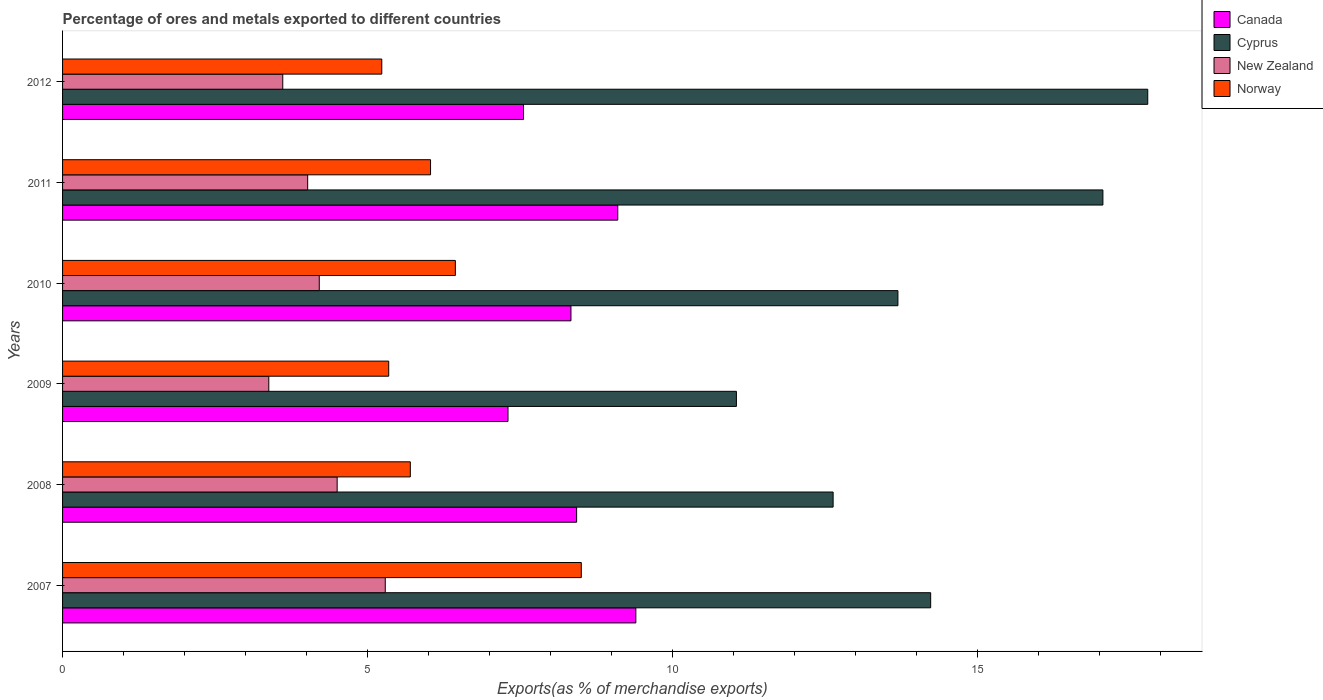How many groups of bars are there?
Provide a short and direct response. 6. How many bars are there on the 6th tick from the bottom?
Provide a succinct answer. 4. What is the label of the 5th group of bars from the top?
Ensure brevity in your answer.  2008. What is the percentage of exports to different countries in New Zealand in 2011?
Keep it short and to the point. 4.02. Across all years, what is the maximum percentage of exports to different countries in Canada?
Provide a succinct answer. 9.4. Across all years, what is the minimum percentage of exports to different countries in Cyprus?
Give a very brief answer. 11.04. In which year was the percentage of exports to different countries in New Zealand minimum?
Provide a succinct answer. 2009. What is the total percentage of exports to different countries in Canada in the graph?
Your answer should be compact. 50.1. What is the difference between the percentage of exports to different countries in Canada in 2008 and that in 2012?
Your response must be concise. 0.87. What is the difference between the percentage of exports to different countries in Canada in 2007 and the percentage of exports to different countries in Norway in 2012?
Offer a very short reply. 4.16. What is the average percentage of exports to different countries in Cyprus per year?
Give a very brief answer. 14.4. In the year 2009, what is the difference between the percentage of exports to different countries in Canada and percentage of exports to different countries in Norway?
Your answer should be very brief. 1.95. What is the ratio of the percentage of exports to different countries in Norway in 2011 to that in 2012?
Keep it short and to the point. 1.15. Is the difference between the percentage of exports to different countries in Canada in 2007 and 2010 greater than the difference between the percentage of exports to different countries in Norway in 2007 and 2010?
Offer a very short reply. No. What is the difference between the highest and the second highest percentage of exports to different countries in Canada?
Provide a succinct answer. 0.3. What is the difference between the highest and the lowest percentage of exports to different countries in Cyprus?
Your answer should be compact. 6.74. In how many years, is the percentage of exports to different countries in New Zealand greater than the average percentage of exports to different countries in New Zealand taken over all years?
Your answer should be very brief. 3. What does the 4th bar from the top in 2009 represents?
Make the answer very short. Canada. Is it the case that in every year, the sum of the percentage of exports to different countries in Canada and percentage of exports to different countries in Norway is greater than the percentage of exports to different countries in New Zealand?
Ensure brevity in your answer.  Yes. How many bars are there?
Ensure brevity in your answer.  24. Are all the bars in the graph horizontal?
Keep it short and to the point. Yes. What is the difference between two consecutive major ticks on the X-axis?
Keep it short and to the point. 5. Are the values on the major ticks of X-axis written in scientific E-notation?
Ensure brevity in your answer.  No. Does the graph contain any zero values?
Provide a succinct answer. No. How are the legend labels stacked?
Give a very brief answer. Vertical. What is the title of the graph?
Ensure brevity in your answer.  Percentage of ores and metals exported to different countries. Does "Monaco" appear as one of the legend labels in the graph?
Offer a terse response. No. What is the label or title of the X-axis?
Ensure brevity in your answer.  Exports(as % of merchandise exports). What is the label or title of the Y-axis?
Provide a short and direct response. Years. What is the Exports(as % of merchandise exports) of Canada in 2007?
Offer a very short reply. 9.4. What is the Exports(as % of merchandise exports) in Cyprus in 2007?
Your answer should be very brief. 14.23. What is the Exports(as % of merchandise exports) of New Zealand in 2007?
Your response must be concise. 5.29. What is the Exports(as % of merchandise exports) of Norway in 2007?
Provide a succinct answer. 8.5. What is the Exports(as % of merchandise exports) in Canada in 2008?
Offer a very short reply. 8.42. What is the Exports(as % of merchandise exports) in Cyprus in 2008?
Ensure brevity in your answer.  12.63. What is the Exports(as % of merchandise exports) in New Zealand in 2008?
Provide a short and direct response. 4.5. What is the Exports(as % of merchandise exports) of Norway in 2008?
Ensure brevity in your answer.  5.7. What is the Exports(as % of merchandise exports) in Canada in 2009?
Provide a succinct answer. 7.3. What is the Exports(as % of merchandise exports) in Cyprus in 2009?
Offer a very short reply. 11.04. What is the Exports(as % of merchandise exports) in New Zealand in 2009?
Provide a short and direct response. 3.38. What is the Exports(as % of merchandise exports) in Norway in 2009?
Keep it short and to the point. 5.35. What is the Exports(as % of merchandise exports) of Canada in 2010?
Your answer should be very brief. 8.33. What is the Exports(as % of merchandise exports) of Cyprus in 2010?
Your answer should be very brief. 13.69. What is the Exports(as % of merchandise exports) of New Zealand in 2010?
Offer a terse response. 4.21. What is the Exports(as % of merchandise exports) of Norway in 2010?
Your response must be concise. 6.44. What is the Exports(as % of merchandise exports) of Canada in 2011?
Offer a terse response. 9.1. What is the Exports(as % of merchandise exports) of Cyprus in 2011?
Your response must be concise. 17.05. What is the Exports(as % of merchandise exports) in New Zealand in 2011?
Your response must be concise. 4.02. What is the Exports(as % of merchandise exports) of Norway in 2011?
Keep it short and to the point. 6.03. What is the Exports(as % of merchandise exports) in Canada in 2012?
Keep it short and to the point. 7.55. What is the Exports(as % of merchandise exports) of Cyprus in 2012?
Keep it short and to the point. 17.78. What is the Exports(as % of merchandise exports) in New Zealand in 2012?
Offer a terse response. 3.61. What is the Exports(as % of merchandise exports) of Norway in 2012?
Ensure brevity in your answer.  5.23. Across all years, what is the maximum Exports(as % of merchandise exports) of Canada?
Make the answer very short. 9.4. Across all years, what is the maximum Exports(as % of merchandise exports) in Cyprus?
Provide a succinct answer. 17.78. Across all years, what is the maximum Exports(as % of merchandise exports) in New Zealand?
Offer a very short reply. 5.29. Across all years, what is the maximum Exports(as % of merchandise exports) in Norway?
Offer a very short reply. 8.5. Across all years, what is the minimum Exports(as % of merchandise exports) in Canada?
Give a very brief answer. 7.3. Across all years, what is the minimum Exports(as % of merchandise exports) in Cyprus?
Your answer should be very brief. 11.04. Across all years, what is the minimum Exports(as % of merchandise exports) of New Zealand?
Your response must be concise. 3.38. Across all years, what is the minimum Exports(as % of merchandise exports) of Norway?
Offer a very short reply. 5.23. What is the total Exports(as % of merchandise exports) of Canada in the graph?
Offer a terse response. 50.1. What is the total Exports(as % of merchandise exports) in Cyprus in the graph?
Keep it short and to the point. 86.42. What is the total Exports(as % of merchandise exports) of New Zealand in the graph?
Your response must be concise. 25. What is the total Exports(as % of merchandise exports) in Norway in the graph?
Make the answer very short. 37.24. What is the difference between the Exports(as % of merchandise exports) of Canada in 2007 and that in 2008?
Make the answer very short. 0.97. What is the difference between the Exports(as % of merchandise exports) of Cyprus in 2007 and that in 2008?
Offer a very short reply. 1.6. What is the difference between the Exports(as % of merchandise exports) of New Zealand in 2007 and that in 2008?
Provide a succinct answer. 0.79. What is the difference between the Exports(as % of merchandise exports) of Norway in 2007 and that in 2008?
Provide a short and direct response. 2.8. What is the difference between the Exports(as % of merchandise exports) of Canada in 2007 and that in 2009?
Ensure brevity in your answer.  2.1. What is the difference between the Exports(as % of merchandise exports) of Cyprus in 2007 and that in 2009?
Ensure brevity in your answer.  3.18. What is the difference between the Exports(as % of merchandise exports) in New Zealand in 2007 and that in 2009?
Your answer should be compact. 1.91. What is the difference between the Exports(as % of merchandise exports) of Norway in 2007 and that in 2009?
Offer a very short reply. 3.16. What is the difference between the Exports(as % of merchandise exports) in Canada in 2007 and that in 2010?
Your response must be concise. 1.06. What is the difference between the Exports(as % of merchandise exports) of Cyprus in 2007 and that in 2010?
Offer a terse response. 0.54. What is the difference between the Exports(as % of merchandise exports) of New Zealand in 2007 and that in 2010?
Give a very brief answer. 1.08. What is the difference between the Exports(as % of merchandise exports) of Norway in 2007 and that in 2010?
Offer a very short reply. 2.06. What is the difference between the Exports(as % of merchandise exports) in Canada in 2007 and that in 2011?
Make the answer very short. 0.3. What is the difference between the Exports(as % of merchandise exports) of Cyprus in 2007 and that in 2011?
Your answer should be very brief. -2.82. What is the difference between the Exports(as % of merchandise exports) of New Zealand in 2007 and that in 2011?
Provide a succinct answer. 1.27. What is the difference between the Exports(as % of merchandise exports) of Norway in 2007 and that in 2011?
Offer a terse response. 2.47. What is the difference between the Exports(as % of merchandise exports) of Canada in 2007 and that in 2012?
Provide a short and direct response. 1.84. What is the difference between the Exports(as % of merchandise exports) of Cyprus in 2007 and that in 2012?
Provide a succinct answer. -3.56. What is the difference between the Exports(as % of merchandise exports) of New Zealand in 2007 and that in 2012?
Ensure brevity in your answer.  1.68. What is the difference between the Exports(as % of merchandise exports) of Norway in 2007 and that in 2012?
Your answer should be compact. 3.27. What is the difference between the Exports(as % of merchandise exports) in Canada in 2008 and that in 2009?
Provide a short and direct response. 1.12. What is the difference between the Exports(as % of merchandise exports) of Cyprus in 2008 and that in 2009?
Your answer should be very brief. 1.58. What is the difference between the Exports(as % of merchandise exports) of New Zealand in 2008 and that in 2009?
Offer a terse response. 1.12. What is the difference between the Exports(as % of merchandise exports) in Norway in 2008 and that in 2009?
Give a very brief answer. 0.35. What is the difference between the Exports(as % of merchandise exports) in Canada in 2008 and that in 2010?
Your response must be concise. 0.09. What is the difference between the Exports(as % of merchandise exports) of Cyprus in 2008 and that in 2010?
Offer a very short reply. -1.06. What is the difference between the Exports(as % of merchandise exports) in New Zealand in 2008 and that in 2010?
Offer a very short reply. 0.29. What is the difference between the Exports(as % of merchandise exports) of Norway in 2008 and that in 2010?
Provide a short and direct response. -0.74. What is the difference between the Exports(as % of merchandise exports) of Canada in 2008 and that in 2011?
Offer a terse response. -0.67. What is the difference between the Exports(as % of merchandise exports) in Cyprus in 2008 and that in 2011?
Make the answer very short. -4.42. What is the difference between the Exports(as % of merchandise exports) in New Zealand in 2008 and that in 2011?
Make the answer very short. 0.48. What is the difference between the Exports(as % of merchandise exports) in Norway in 2008 and that in 2011?
Give a very brief answer. -0.33. What is the difference between the Exports(as % of merchandise exports) of Canada in 2008 and that in 2012?
Offer a very short reply. 0.87. What is the difference between the Exports(as % of merchandise exports) in Cyprus in 2008 and that in 2012?
Make the answer very short. -5.16. What is the difference between the Exports(as % of merchandise exports) in New Zealand in 2008 and that in 2012?
Your answer should be very brief. 0.89. What is the difference between the Exports(as % of merchandise exports) of Norway in 2008 and that in 2012?
Your answer should be very brief. 0.47. What is the difference between the Exports(as % of merchandise exports) of Canada in 2009 and that in 2010?
Your answer should be compact. -1.03. What is the difference between the Exports(as % of merchandise exports) of Cyprus in 2009 and that in 2010?
Provide a short and direct response. -2.65. What is the difference between the Exports(as % of merchandise exports) of New Zealand in 2009 and that in 2010?
Your response must be concise. -0.83. What is the difference between the Exports(as % of merchandise exports) in Norway in 2009 and that in 2010?
Your response must be concise. -1.09. What is the difference between the Exports(as % of merchandise exports) of Canada in 2009 and that in 2011?
Provide a short and direct response. -1.8. What is the difference between the Exports(as % of merchandise exports) of Cyprus in 2009 and that in 2011?
Your answer should be compact. -6.01. What is the difference between the Exports(as % of merchandise exports) in New Zealand in 2009 and that in 2011?
Keep it short and to the point. -0.64. What is the difference between the Exports(as % of merchandise exports) in Norway in 2009 and that in 2011?
Provide a short and direct response. -0.69. What is the difference between the Exports(as % of merchandise exports) in Canada in 2009 and that in 2012?
Provide a short and direct response. -0.25. What is the difference between the Exports(as % of merchandise exports) of Cyprus in 2009 and that in 2012?
Give a very brief answer. -6.74. What is the difference between the Exports(as % of merchandise exports) of New Zealand in 2009 and that in 2012?
Offer a terse response. -0.23. What is the difference between the Exports(as % of merchandise exports) of Norway in 2009 and that in 2012?
Offer a terse response. 0.11. What is the difference between the Exports(as % of merchandise exports) in Canada in 2010 and that in 2011?
Give a very brief answer. -0.77. What is the difference between the Exports(as % of merchandise exports) in Cyprus in 2010 and that in 2011?
Provide a short and direct response. -3.36. What is the difference between the Exports(as % of merchandise exports) of New Zealand in 2010 and that in 2011?
Provide a succinct answer. 0.19. What is the difference between the Exports(as % of merchandise exports) of Norway in 2010 and that in 2011?
Ensure brevity in your answer.  0.41. What is the difference between the Exports(as % of merchandise exports) of Canada in 2010 and that in 2012?
Keep it short and to the point. 0.78. What is the difference between the Exports(as % of merchandise exports) in Cyprus in 2010 and that in 2012?
Offer a very short reply. -4.09. What is the difference between the Exports(as % of merchandise exports) in New Zealand in 2010 and that in 2012?
Keep it short and to the point. 0.6. What is the difference between the Exports(as % of merchandise exports) in Norway in 2010 and that in 2012?
Make the answer very short. 1.21. What is the difference between the Exports(as % of merchandise exports) in Canada in 2011 and that in 2012?
Provide a short and direct response. 1.54. What is the difference between the Exports(as % of merchandise exports) of Cyprus in 2011 and that in 2012?
Give a very brief answer. -0.73. What is the difference between the Exports(as % of merchandise exports) of New Zealand in 2011 and that in 2012?
Keep it short and to the point. 0.41. What is the difference between the Exports(as % of merchandise exports) of Norway in 2011 and that in 2012?
Your response must be concise. 0.8. What is the difference between the Exports(as % of merchandise exports) in Canada in 2007 and the Exports(as % of merchandise exports) in Cyprus in 2008?
Keep it short and to the point. -3.23. What is the difference between the Exports(as % of merchandise exports) in Canada in 2007 and the Exports(as % of merchandise exports) in New Zealand in 2008?
Provide a short and direct response. 4.89. What is the difference between the Exports(as % of merchandise exports) of Canada in 2007 and the Exports(as % of merchandise exports) of Norway in 2008?
Offer a terse response. 3.7. What is the difference between the Exports(as % of merchandise exports) in Cyprus in 2007 and the Exports(as % of merchandise exports) in New Zealand in 2008?
Your response must be concise. 9.73. What is the difference between the Exports(as % of merchandise exports) in Cyprus in 2007 and the Exports(as % of merchandise exports) in Norway in 2008?
Offer a terse response. 8.53. What is the difference between the Exports(as % of merchandise exports) of New Zealand in 2007 and the Exports(as % of merchandise exports) of Norway in 2008?
Provide a succinct answer. -0.41. What is the difference between the Exports(as % of merchandise exports) in Canada in 2007 and the Exports(as % of merchandise exports) in Cyprus in 2009?
Make the answer very short. -1.65. What is the difference between the Exports(as % of merchandise exports) of Canada in 2007 and the Exports(as % of merchandise exports) of New Zealand in 2009?
Give a very brief answer. 6.02. What is the difference between the Exports(as % of merchandise exports) of Canada in 2007 and the Exports(as % of merchandise exports) of Norway in 2009?
Ensure brevity in your answer.  4.05. What is the difference between the Exports(as % of merchandise exports) in Cyprus in 2007 and the Exports(as % of merchandise exports) in New Zealand in 2009?
Your response must be concise. 10.85. What is the difference between the Exports(as % of merchandise exports) of Cyprus in 2007 and the Exports(as % of merchandise exports) of Norway in 2009?
Offer a terse response. 8.88. What is the difference between the Exports(as % of merchandise exports) of New Zealand in 2007 and the Exports(as % of merchandise exports) of Norway in 2009?
Your answer should be compact. -0.06. What is the difference between the Exports(as % of merchandise exports) in Canada in 2007 and the Exports(as % of merchandise exports) in Cyprus in 2010?
Offer a very short reply. -4.29. What is the difference between the Exports(as % of merchandise exports) in Canada in 2007 and the Exports(as % of merchandise exports) in New Zealand in 2010?
Give a very brief answer. 5.19. What is the difference between the Exports(as % of merchandise exports) in Canada in 2007 and the Exports(as % of merchandise exports) in Norway in 2010?
Your answer should be very brief. 2.96. What is the difference between the Exports(as % of merchandise exports) in Cyprus in 2007 and the Exports(as % of merchandise exports) in New Zealand in 2010?
Provide a short and direct response. 10.02. What is the difference between the Exports(as % of merchandise exports) of Cyprus in 2007 and the Exports(as % of merchandise exports) of Norway in 2010?
Provide a short and direct response. 7.79. What is the difference between the Exports(as % of merchandise exports) in New Zealand in 2007 and the Exports(as % of merchandise exports) in Norway in 2010?
Provide a short and direct response. -1.15. What is the difference between the Exports(as % of merchandise exports) in Canada in 2007 and the Exports(as % of merchandise exports) in Cyprus in 2011?
Provide a succinct answer. -7.65. What is the difference between the Exports(as % of merchandise exports) in Canada in 2007 and the Exports(as % of merchandise exports) in New Zealand in 2011?
Offer a terse response. 5.38. What is the difference between the Exports(as % of merchandise exports) of Canada in 2007 and the Exports(as % of merchandise exports) of Norway in 2011?
Provide a short and direct response. 3.36. What is the difference between the Exports(as % of merchandise exports) in Cyprus in 2007 and the Exports(as % of merchandise exports) in New Zealand in 2011?
Offer a terse response. 10.21. What is the difference between the Exports(as % of merchandise exports) in Cyprus in 2007 and the Exports(as % of merchandise exports) in Norway in 2011?
Provide a short and direct response. 8.2. What is the difference between the Exports(as % of merchandise exports) in New Zealand in 2007 and the Exports(as % of merchandise exports) in Norway in 2011?
Your answer should be very brief. -0.74. What is the difference between the Exports(as % of merchandise exports) in Canada in 2007 and the Exports(as % of merchandise exports) in Cyprus in 2012?
Make the answer very short. -8.39. What is the difference between the Exports(as % of merchandise exports) of Canada in 2007 and the Exports(as % of merchandise exports) of New Zealand in 2012?
Provide a succinct answer. 5.79. What is the difference between the Exports(as % of merchandise exports) in Canada in 2007 and the Exports(as % of merchandise exports) in Norway in 2012?
Provide a short and direct response. 4.16. What is the difference between the Exports(as % of merchandise exports) of Cyprus in 2007 and the Exports(as % of merchandise exports) of New Zealand in 2012?
Your response must be concise. 10.62. What is the difference between the Exports(as % of merchandise exports) of Cyprus in 2007 and the Exports(as % of merchandise exports) of Norway in 2012?
Ensure brevity in your answer.  9. What is the difference between the Exports(as % of merchandise exports) in New Zealand in 2007 and the Exports(as % of merchandise exports) in Norway in 2012?
Keep it short and to the point. 0.06. What is the difference between the Exports(as % of merchandise exports) of Canada in 2008 and the Exports(as % of merchandise exports) of Cyprus in 2009?
Provide a short and direct response. -2.62. What is the difference between the Exports(as % of merchandise exports) in Canada in 2008 and the Exports(as % of merchandise exports) in New Zealand in 2009?
Offer a terse response. 5.04. What is the difference between the Exports(as % of merchandise exports) in Canada in 2008 and the Exports(as % of merchandise exports) in Norway in 2009?
Provide a succinct answer. 3.08. What is the difference between the Exports(as % of merchandise exports) in Cyprus in 2008 and the Exports(as % of merchandise exports) in New Zealand in 2009?
Offer a very short reply. 9.25. What is the difference between the Exports(as % of merchandise exports) of Cyprus in 2008 and the Exports(as % of merchandise exports) of Norway in 2009?
Your response must be concise. 7.28. What is the difference between the Exports(as % of merchandise exports) of New Zealand in 2008 and the Exports(as % of merchandise exports) of Norway in 2009?
Your answer should be very brief. -0.85. What is the difference between the Exports(as % of merchandise exports) in Canada in 2008 and the Exports(as % of merchandise exports) in Cyprus in 2010?
Your answer should be compact. -5.27. What is the difference between the Exports(as % of merchandise exports) in Canada in 2008 and the Exports(as % of merchandise exports) in New Zealand in 2010?
Provide a short and direct response. 4.22. What is the difference between the Exports(as % of merchandise exports) of Canada in 2008 and the Exports(as % of merchandise exports) of Norway in 2010?
Keep it short and to the point. 1.99. What is the difference between the Exports(as % of merchandise exports) in Cyprus in 2008 and the Exports(as % of merchandise exports) in New Zealand in 2010?
Your answer should be very brief. 8.42. What is the difference between the Exports(as % of merchandise exports) in Cyprus in 2008 and the Exports(as % of merchandise exports) in Norway in 2010?
Make the answer very short. 6.19. What is the difference between the Exports(as % of merchandise exports) of New Zealand in 2008 and the Exports(as % of merchandise exports) of Norway in 2010?
Offer a terse response. -1.94. What is the difference between the Exports(as % of merchandise exports) of Canada in 2008 and the Exports(as % of merchandise exports) of Cyprus in 2011?
Offer a terse response. -8.62. What is the difference between the Exports(as % of merchandise exports) in Canada in 2008 and the Exports(as % of merchandise exports) in New Zealand in 2011?
Provide a succinct answer. 4.41. What is the difference between the Exports(as % of merchandise exports) of Canada in 2008 and the Exports(as % of merchandise exports) of Norway in 2011?
Give a very brief answer. 2.39. What is the difference between the Exports(as % of merchandise exports) in Cyprus in 2008 and the Exports(as % of merchandise exports) in New Zealand in 2011?
Keep it short and to the point. 8.61. What is the difference between the Exports(as % of merchandise exports) in Cyprus in 2008 and the Exports(as % of merchandise exports) in Norway in 2011?
Provide a short and direct response. 6.6. What is the difference between the Exports(as % of merchandise exports) in New Zealand in 2008 and the Exports(as % of merchandise exports) in Norway in 2011?
Your answer should be compact. -1.53. What is the difference between the Exports(as % of merchandise exports) of Canada in 2008 and the Exports(as % of merchandise exports) of Cyprus in 2012?
Offer a very short reply. -9.36. What is the difference between the Exports(as % of merchandise exports) of Canada in 2008 and the Exports(as % of merchandise exports) of New Zealand in 2012?
Provide a short and direct response. 4.82. What is the difference between the Exports(as % of merchandise exports) of Canada in 2008 and the Exports(as % of merchandise exports) of Norway in 2012?
Offer a very short reply. 3.19. What is the difference between the Exports(as % of merchandise exports) of Cyprus in 2008 and the Exports(as % of merchandise exports) of New Zealand in 2012?
Make the answer very short. 9.02. What is the difference between the Exports(as % of merchandise exports) in Cyprus in 2008 and the Exports(as % of merchandise exports) in Norway in 2012?
Make the answer very short. 7.4. What is the difference between the Exports(as % of merchandise exports) of New Zealand in 2008 and the Exports(as % of merchandise exports) of Norway in 2012?
Provide a succinct answer. -0.73. What is the difference between the Exports(as % of merchandise exports) of Canada in 2009 and the Exports(as % of merchandise exports) of Cyprus in 2010?
Give a very brief answer. -6.39. What is the difference between the Exports(as % of merchandise exports) of Canada in 2009 and the Exports(as % of merchandise exports) of New Zealand in 2010?
Keep it short and to the point. 3.09. What is the difference between the Exports(as % of merchandise exports) of Canada in 2009 and the Exports(as % of merchandise exports) of Norway in 2010?
Offer a very short reply. 0.86. What is the difference between the Exports(as % of merchandise exports) of Cyprus in 2009 and the Exports(as % of merchandise exports) of New Zealand in 2010?
Give a very brief answer. 6.84. What is the difference between the Exports(as % of merchandise exports) in Cyprus in 2009 and the Exports(as % of merchandise exports) in Norway in 2010?
Keep it short and to the point. 4.61. What is the difference between the Exports(as % of merchandise exports) of New Zealand in 2009 and the Exports(as % of merchandise exports) of Norway in 2010?
Ensure brevity in your answer.  -3.06. What is the difference between the Exports(as % of merchandise exports) in Canada in 2009 and the Exports(as % of merchandise exports) in Cyprus in 2011?
Make the answer very short. -9.75. What is the difference between the Exports(as % of merchandise exports) of Canada in 2009 and the Exports(as % of merchandise exports) of New Zealand in 2011?
Your answer should be very brief. 3.28. What is the difference between the Exports(as % of merchandise exports) in Canada in 2009 and the Exports(as % of merchandise exports) in Norway in 2011?
Your answer should be very brief. 1.27. What is the difference between the Exports(as % of merchandise exports) of Cyprus in 2009 and the Exports(as % of merchandise exports) of New Zealand in 2011?
Keep it short and to the point. 7.03. What is the difference between the Exports(as % of merchandise exports) in Cyprus in 2009 and the Exports(as % of merchandise exports) in Norway in 2011?
Keep it short and to the point. 5.01. What is the difference between the Exports(as % of merchandise exports) in New Zealand in 2009 and the Exports(as % of merchandise exports) in Norway in 2011?
Your response must be concise. -2.65. What is the difference between the Exports(as % of merchandise exports) in Canada in 2009 and the Exports(as % of merchandise exports) in Cyprus in 2012?
Keep it short and to the point. -10.48. What is the difference between the Exports(as % of merchandise exports) in Canada in 2009 and the Exports(as % of merchandise exports) in New Zealand in 2012?
Provide a succinct answer. 3.69. What is the difference between the Exports(as % of merchandise exports) of Canada in 2009 and the Exports(as % of merchandise exports) of Norway in 2012?
Give a very brief answer. 2.07. What is the difference between the Exports(as % of merchandise exports) in Cyprus in 2009 and the Exports(as % of merchandise exports) in New Zealand in 2012?
Ensure brevity in your answer.  7.43. What is the difference between the Exports(as % of merchandise exports) of Cyprus in 2009 and the Exports(as % of merchandise exports) of Norway in 2012?
Ensure brevity in your answer.  5.81. What is the difference between the Exports(as % of merchandise exports) in New Zealand in 2009 and the Exports(as % of merchandise exports) in Norway in 2012?
Make the answer very short. -1.85. What is the difference between the Exports(as % of merchandise exports) of Canada in 2010 and the Exports(as % of merchandise exports) of Cyprus in 2011?
Provide a succinct answer. -8.72. What is the difference between the Exports(as % of merchandise exports) in Canada in 2010 and the Exports(as % of merchandise exports) in New Zealand in 2011?
Your answer should be very brief. 4.31. What is the difference between the Exports(as % of merchandise exports) in Canada in 2010 and the Exports(as % of merchandise exports) in Norway in 2011?
Ensure brevity in your answer.  2.3. What is the difference between the Exports(as % of merchandise exports) in Cyprus in 2010 and the Exports(as % of merchandise exports) in New Zealand in 2011?
Offer a very short reply. 9.67. What is the difference between the Exports(as % of merchandise exports) in Cyprus in 2010 and the Exports(as % of merchandise exports) in Norway in 2011?
Provide a short and direct response. 7.66. What is the difference between the Exports(as % of merchandise exports) in New Zealand in 2010 and the Exports(as % of merchandise exports) in Norway in 2011?
Provide a short and direct response. -1.82. What is the difference between the Exports(as % of merchandise exports) of Canada in 2010 and the Exports(as % of merchandise exports) of Cyprus in 2012?
Make the answer very short. -9.45. What is the difference between the Exports(as % of merchandise exports) of Canada in 2010 and the Exports(as % of merchandise exports) of New Zealand in 2012?
Offer a terse response. 4.72. What is the difference between the Exports(as % of merchandise exports) in Canada in 2010 and the Exports(as % of merchandise exports) in Norway in 2012?
Your response must be concise. 3.1. What is the difference between the Exports(as % of merchandise exports) in Cyprus in 2010 and the Exports(as % of merchandise exports) in New Zealand in 2012?
Make the answer very short. 10.08. What is the difference between the Exports(as % of merchandise exports) in Cyprus in 2010 and the Exports(as % of merchandise exports) in Norway in 2012?
Ensure brevity in your answer.  8.46. What is the difference between the Exports(as % of merchandise exports) of New Zealand in 2010 and the Exports(as % of merchandise exports) of Norway in 2012?
Your answer should be very brief. -1.02. What is the difference between the Exports(as % of merchandise exports) of Canada in 2011 and the Exports(as % of merchandise exports) of Cyprus in 2012?
Your answer should be compact. -8.69. What is the difference between the Exports(as % of merchandise exports) of Canada in 2011 and the Exports(as % of merchandise exports) of New Zealand in 2012?
Give a very brief answer. 5.49. What is the difference between the Exports(as % of merchandise exports) of Canada in 2011 and the Exports(as % of merchandise exports) of Norway in 2012?
Offer a terse response. 3.87. What is the difference between the Exports(as % of merchandise exports) in Cyprus in 2011 and the Exports(as % of merchandise exports) in New Zealand in 2012?
Offer a terse response. 13.44. What is the difference between the Exports(as % of merchandise exports) of Cyprus in 2011 and the Exports(as % of merchandise exports) of Norway in 2012?
Give a very brief answer. 11.82. What is the difference between the Exports(as % of merchandise exports) of New Zealand in 2011 and the Exports(as % of merchandise exports) of Norway in 2012?
Provide a succinct answer. -1.21. What is the average Exports(as % of merchandise exports) of Canada per year?
Provide a short and direct response. 8.35. What is the average Exports(as % of merchandise exports) of Cyprus per year?
Keep it short and to the point. 14.4. What is the average Exports(as % of merchandise exports) in New Zealand per year?
Provide a succinct answer. 4.17. What is the average Exports(as % of merchandise exports) in Norway per year?
Make the answer very short. 6.21. In the year 2007, what is the difference between the Exports(as % of merchandise exports) in Canada and Exports(as % of merchandise exports) in Cyprus?
Offer a very short reply. -4.83. In the year 2007, what is the difference between the Exports(as % of merchandise exports) in Canada and Exports(as % of merchandise exports) in New Zealand?
Provide a short and direct response. 4.11. In the year 2007, what is the difference between the Exports(as % of merchandise exports) of Canada and Exports(as % of merchandise exports) of Norway?
Your answer should be very brief. 0.89. In the year 2007, what is the difference between the Exports(as % of merchandise exports) of Cyprus and Exports(as % of merchandise exports) of New Zealand?
Offer a terse response. 8.94. In the year 2007, what is the difference between the Exports(as % of merchandise exports) of Cyprus and Exports(as % of merchandise exports) of Norway?
Your response must be concise. 5.73. In the year 2007, what is the difference between the Exports(as % of merchandise exports) in New Zealand and Exports(as % of merchandise exports) in Norway?
Make the answer very short. -3.21. In the year 2008, what is the difference between the Exports(as % of merchandise exports) in Canada and Exports(as % of merchandise exports) in Cyprus?
Your answer should be compact. -4.2. In the year 2008, what is the difference between the Exports(as % of merchandise exports) in Canada and Exports(as % of merchandise exports) in New Zealand?
Offer a very short reply. 3.92. In the year 2008, what is the difference between the Exports(as % of merchandise exports) of Canada and Exports(as % of merchandise exports) of Norway?
Offer a terse response. 2.73. In the year 2008, what is the difference between the Exports(as % of merchandise exports) of Cyprus and Exports(as % of merchandise exports) of New Zealand?
Offer a terse response. 8.13. In the year 2008, what is the difference between the Exports(as % of merchandise exports) of Cyprus and Exports(as % of merchandise exports) of Norway?
Make the answer very short. 6.93. In the year 2008, what is the difference between the Exports(as % of merchandise exports) in New Zealand and Exports(as % of merchandise exports) in Norway?
Offer a terse response. -1.2. In the year 2009, what is the difference between the Exports(as % of merchandise exports) in Canada and Exports(as % of merchandise exports) in Cyprus?
Provide a succinct answer. -3.74. In the year 2009, what is the difference between the Exports(as % of merchandise exports) of Canada and Exports(as % of merchandise exports) of New Zealand?
Make the answer very short. 3.92. In the year 2009, what is the difference between the Exports(as % of merchandise exports) in Canada and Exports(as % of merchandise exports) in Norway?
Your answer should be very brief. 1.95. In the year 2009, what is the difference between the Exports(as % of merchandise exports) of Cyprus and Exports(as % of merchandise exports) of New Zealand?
Keep it short and to the point. 7.66. In the year 2009, what is the difference between the Exports(as % of merchandise exports) of Cyprus and Exports(as % of merchandise exports) of Norway?
Provide a short and direct response. 5.7. In the year 2009, what is the difference between the Exports(as % of merchandise exports) in New Zealand and Exports(as % of merchandise exports) in Norway?
Your answer should be very brief. -1.97. In the year 2010, what is the difference between the Exports(as % of merchandise exports) of Canada and Exports(as % of merchandise exports) of Cyprus?
Make the answer very short. -5.36. In the year 2010, what is the difference between the Exports(as % of merchandise exports) in Canada and Exports(as % of merchandise exports) in New Zealand?
Your answer should be very brief. 4.12. In the year 2010, what is the difference between the Exports(as % of merchandise exports) in Canada and Exports(as % of merchandise exports) in Norway?
Give a very brief answer. 1.89. In the year 2010, what is the difference between the Exports(as % of merchandise exports) of Cyprus and Exports(as % of merchandise exports) of New Zealand?
Your response must be concise. 9.48. In the year 2010, what is the difference between the Exports(as % of merchandise exports) of Cyprus and Exports(as % of merchandise exports) of Norway?
Your response must be concise. 7.25. In the year 2010, what is the difference between the Exports(as % of merchandise exports) in New Zealand and Exports(as % of merchandise exports) in Norway?
Ensure brevity in your answer.  -2.23. In the year 2011, what is the difference between the Exports(as % of merchandise exports) of Canada and Exports(as % of merchandise exports) of Cyprus?
Give a very brief answer. -7.95. In the year 2011, what is the difference between the Exports(as % of merchandise exports) in Canada and Exports(as % of merchandise exports) in New Zealand?
Your answer should be compact. 5.08. In the year 2011, what is the difference between the Exports(as % of merchandise exports) of Canada and Exports(as % of merchandise exports) of Norway?
Keep it short and to the point. 3.07. In the year 2011, what is the difference between the Exports(as % of merchandise exports) in Cyprus and Exports(as % of merchandise exports) in New Zealand?
Make the answer very short. 13.03. In the year 2011, what is the difference between the Exports(as % of merchandise exports) in Cyprus and Exports(as % of merchandise exports) in Norway?
Give a very brief answer. 11.02. In the year 2011, what is the difference between the Exports(as % of merchandise exports) in New Zealand and Exports(as % of merchandise exports) in Norway?
Your answer should be very brief. -2.01. In the year 2012, what is the difference between the Exports(as % of merchandise exports) in Canada and Exports(as % of merchandise exports) in Cyprus?
Your answer should be compact. -10.23. In the year 2012, what is the difference between the Exports(as % of merchandise exports) of Canada and Exports(as % of merchandise exports) of New Zealand?
Offer a very short reply. 3.95. In the year 2012, what is the difference between the Exports(as % of merchandise exports) of Canada and Exports(as % of merchandise exports) of Norway?
Your answer should be compact. 2.32. In the year 2012, what is the difference between the Exports(as % of merchandise exports) in Cyprus and Exports(as % of merchandise exports) in New Zealand?
Give a very brief answer. 14.18. In the year 2012, what is the difference between the Exports(as % of merchandise exports) of Cyprus and Exports(as % of merchandise exports) of Norway?
Keep it short and to the point. 12.55. In the year 2012, what is the difference between the Exports(as % of merchandise exports) in New Zealand and Exports(as % of merchandise exports) in Norway?
Keep it short and to the point. -1.62. What is the ratio of the Exports(as % of merchandise exports) of Canada in 2007 to that in 2008?
Make the answer very short. 1.12. What is the ratio of the Exports(as % of merchandise exports) of Cyprus in 2007 to that in 2008?
Give a very brief answer. 1.13. What is the ratio of the Exports(as % of merchandise exports) of New Zealand in 2007 to that in 2008?
Your answer should be very brief. 1.18. What is the ratio of the Exports(as % of merchandise exports) in Norway in 2007 to that in 2008?
Offer a terse response. 1.49. What is the ratio of the Exports(as % of merchandise exports) in Canada in 2007 to that in 2009?
Ensure brevity in your answer.  1.29. What is the ratio of the Exports(as % of merchandise exports) of Cyprus in 2007 to that in 2009?
Give a very brief answer. 1.29. What is the ratio of the Exports(as % of merchandise exports) in New Zealand in 2007 to that in 2009?
Ensure brevity in your answer.  1.56. What is the ratio of the Exports(as % of merchandise exports) of Norway in 2007 to that in 2009?
Keep it short and to the point. 1.59. What is the ratio of the Exports(as % of merchandise exports) of Canada in 2007 to that in 2010?
Your answer should be very brief. 1.13. What is the ratio of the Exports(as % of merchandise exports) of Cyprus in 2007 to that in 2010?
Provide a short and direct response. 1.04. What is the ratio of the Exports(as % of merchandise exports) in New Zealand in 2007 to that in 2010?
Offer a very short reply. 1.26. What is the ratio of the Exports(as % of merchandise exports) in Norway in 2007 to that in 2010?
Offer a terse response. 1.32. What is the ratio of the Exports(as % of merchandise exports) in Canada in 2007 to that in 2011?
Your answer should be very brief. 1.03. What is the ratio of the Exports(as % of merchandise exports) in Cyprus in 2007 to that in 2011?
Offer a terse response. 0.83. What is the ratio of the Exports(as % of merchandise exports) of New Zealand in 2007 to that in 2011?
Your answer should be compact. 1.32. What is the ratio of the Exports(as % of merchandise exports) in Norway in 2007 to that in 2011?
Your response must be concise. 1.41. What is the ratio of the Exports(as % of merchandise exports) in Canada in 2007 to that in 2012?
Keep it short and to the point. 1.24. What is the ratio of the Exports(as % of merchandise exports) of Cyprus in 2007 to that in 2012?
Provide a succinct answer. 0.8. What is the ratio of the Exports(as % of merchandise exports) in New Zealand in 2007 to that in 2012?
Offer a very short reply. 1.47. What is the ratio of the Exports(as % of merchandise exports) in Norway in 2007 to that in 2012?
Offer a very short reply. 1.62. What is the ratio of the Exports(as % of merchandise exports) of Canada in 2008 to that in 2009?
Provide a short and direct response. 1.15. What is the ratio of the Exports(as % of merchandise exports) of Cyprus in 2008 to that in 2009?
Offer a very short reply. 1.14. What is the ratio of the Exports(as % of merchandise exports) of New Zealand in 2008 to that in 2009?
Ensure brevity in your answer.  1.33. What is the ratio of the Exports(as % of merchandise exports) of Norway in 2008 to that in 2009?
Your answer should be very brief. 1.07. What is the ratio of the Exports(as % of merchandise exports) in Canada in 2008 to that in 2010?
Make the answer very short. 1.01. What is the ratio of the Exports(as % of merchandise exports) in Cyprus in 2008 to that in 2010?
Your answer should be very brief. 0.92. What is the ratio of the Exports(as % of merchandise exports) in New Zealand in 2008 to that in 2010?
Your answer should be compact. 1.07. What is the ratio of the Exports(as % of merchandise exports) of Norway in 2008 to that in 2010?
Give a very brief answer. 0.89. What is the ratio of the Exports(as % of merchandise exports) of Canada in 2008 to that in 2011?
Give a very brief answer. 0.93. What is the ratio of the Exports(as % of merchandise exports) of Cyprus in 2008 to that in 2011?
Your answer should be very brief. 0.74. What is the ratio of the Exports(as % of merchandise exports) in New Zealand in 2008 to that in 2011?
Make the answer very short. 1.12. What is the ratio of the Exports(as % of merchandise exports) of Norway in 2008 to that in 2011?
Your answer should be compact. 0.95. What is the ratio of the Exports(as % of merchandise exports) in Canada in 2008 to that in 2012?
Offer a terse response. 1.12. What is the ratio of the Exports(as % of merchandise exports) of Cyprus in 2008 to that in 2012?
Provide a succinct answer. 0.71. What is the ratio of the Exports(as % of merchandise exports) of New Zealand in 2008 to that in 2012?
Ensure brevity in your answer.  1.25. What is the ratio of the Exports(as % of merchandise exports) in Norway in 2008 to that in 2012?
Keep it short and to the point. 1.09. What is the ratio of the Exports(as % of merchandise exports) in Canada in 2009 to that in 2010?
Ensure brevity in your answer.  0.88. What is the ratio of the Exports(as % of merchandise exports) in Cyprus in 2009 to that in 2010?
Provide a short and direct response. 0.81. What is the ratio of the Exports(as % of merchandise exports) in New Zealand in 2009 to that in 2010?
Ensure brevity in your answer.  0.8. What is the ratio of the Exports(as % of merchandise exports) in Norway in 2009 to that in 2010?
Ensure brevity in your answer.  0.83. What is the ratio of the Exports(as % of merchandise exports) in Canada in 2009 to that in 2011?
Provide a short and direct response. 0.8. What is the ratio of the Exports(as % of merchandise exports) of Cyprus in 2009 to that in 2011?
Your answer should be compact. 0.65. What is the ratio of the Exports(as % of merchandise exports) of New Zealand in 2009 to that in 2011?
Give a very brief answer. 0.84. What is the ratio of the Exports(as % of merchandise exports) in Norway in 2009 to that in 2011?
Offer a very short reply. 0.89. What is the ratio of the Exports(as % of merchandise exports) in Canada in 2009 to that in 2012?
Your response must be concise. 0.97. What is the ratio of the Exports(as % of merchandise exports) of Cyprus in 2009 to that in 2012?
Your response must be concise. 0.62. What is the ratio of the Exports(as % of merchandise exports) of New Zealand in 2009 to that in 2012?
Keep it short and to the point. 0.94. What is the ratio of the Exports(as % of merchandise exports) in Norway in 2009 to that in 2012?
Keep it short and to the point. 1.02. What is the ratio of the Exports(as % of merchandise exports) in Canada in 2010 to that in 2011?
Ensure brevity in your answer.  0.92. What is the ratio of the Exports(as % of merchandise exports) of Cyprus in 2010 to that in 2011?
Offer a terse response. 0.8. What is the ratio of the Exports(as % of merchandise exports) of New Zealand in 2010 to that in 2011?
Your answer should be compact. 1.05. What is the ratio of the Exports(as % of merchandise exports) in Norway in 2010 to that in 2011?
Your answer should be very brief. 1.07. What is the ratio of the Exports(as % of merchandise exports) of Canada in 2010 to that in 2012?
Provide a succinct answer. 1.1. What is the ratio of the Exports(as % of merchandise exports) in Cyprus in 2010 to that in 2012?
Offer a very short reply. 0.77. What is the ratio of the Exports(as % of merchandise exports) in New Zealand in 2010 to that in 2012?
Your answer should be compact. 1.17. What is the ratio of the Exports(as % of merchandise exports) of Norway in 2010 to that in 2012?
Offer a terse response. 1.23. What is the ratio of the Exports(as % of merchandise exports) of Canada in 2011 to that in 2012?
Your response must be concise. 1.2. What is the ratio of the Exports(as % of merchandise exports) in Cyprus in 2011 to that in 2012?
Your answer should be compact. 0.96. What is the ratio of the Exports(as % of merchandise exports) in New Zealand in 2011 to that in 2012?
Your answer should be very brief. 1.11. What is the ratio of the Exports(as % of merchandise exports) in Norway in 2011 to that in 2012?
Offer a terse response. 1.15. What is the difference between the highest and the second highest Exports(as % of merchandise exports) of Canada?
Your answer should be compact. 0.3. What is the difference between the highest and the second highest Exports(as % of merchandise exports) in Cyprus?
Keep it short and to the point. 0.73. What is the difference between the highest and the second highest Exports(as % of merchandise exports) of New Zealand?
Offer a terse response. 0.79. What is the difference between the highest and the second highest Exports(as % of merchandise exports) in Norway?
Make the answer very short. 2.06. What is the difference between the highest and the lowest Exports(as % of merchandise exports) in Canada?
Your answer should be compact. 2.1. What is the difference between the highest and the lowest Exports(as % of merchandise exports) of Cyprus?
Your answer should be compact. 6.74. What is the difference between the highest and the lowest Exports(as % of merchandise exports) of New Zealand?
Provide a succinct answer. 1.91. What is the difference between the highest and the lowest Exports(as % of merchandise exports) of Norway?
Your response must be concise. 3.27. 